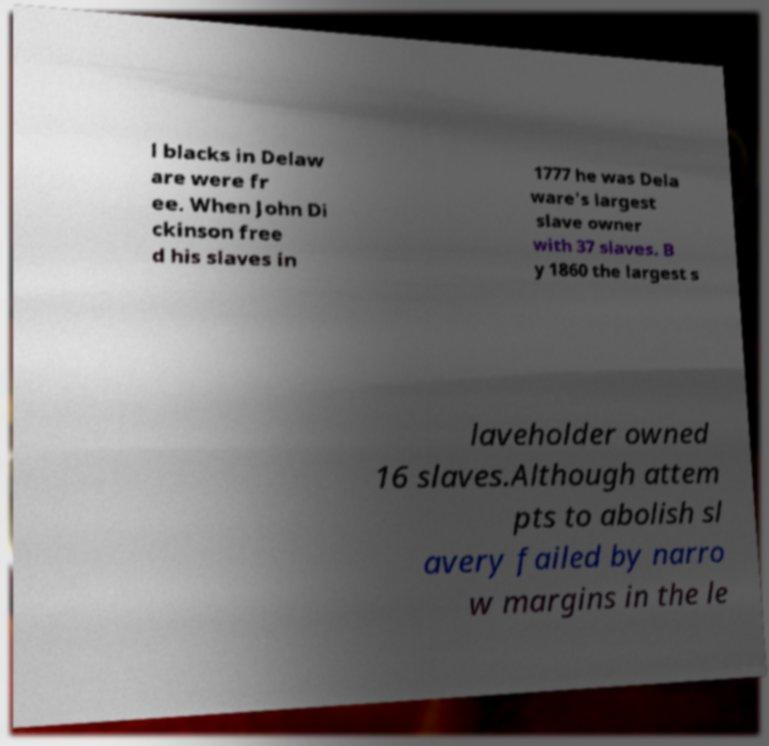Please read and relay the text visible in this image. What does it say? l blacks in Delaw are were fr ee. When John Di ckinson free d his slaves in 1777 he was Dela ware's largest slave owner with 37 slaves. B y 1860 the largest s laveholder owned 16 slaves.Although attem pts to abolish sl avery failed by narro w margins in the le 